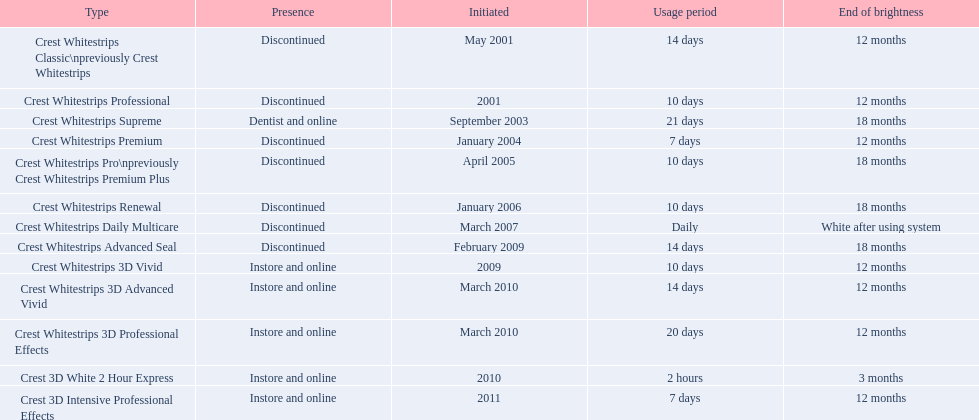Is each white strip discontinued? No. 